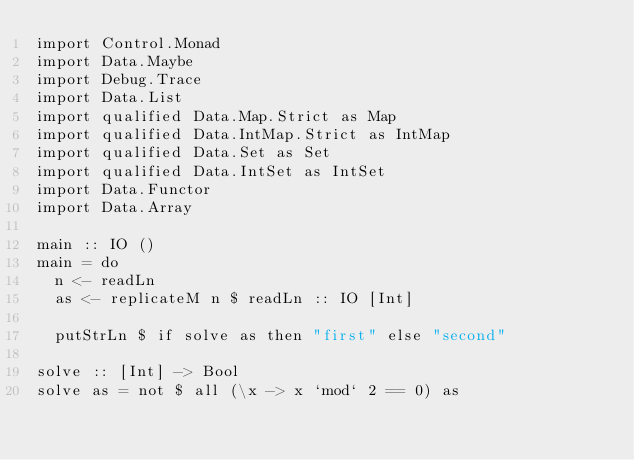<code> <loc_0><loc_0><loc_500><loc_500><_Haskell_>import Control.Monad
import Data.Maybe
import Debug.Trace
import Data.List
import qualified Data.Map.Strict as Map
import qualified Data.IntMap.Strict as IntMap
import qualified Data.Set as Set
import qualified Data.IntSet as IntSet
import Data.Functor
import Data.Array

main :: IO ()
main = do
  n <- readLn
  as <- replicateM n $ readLn :: IO [Int]

  putStrLn $ if solve as then "first" else "second"

solve :: [Int] -> Bool
solve as = not $ all (\x -> x `mod` 2 == 0) as </code> 